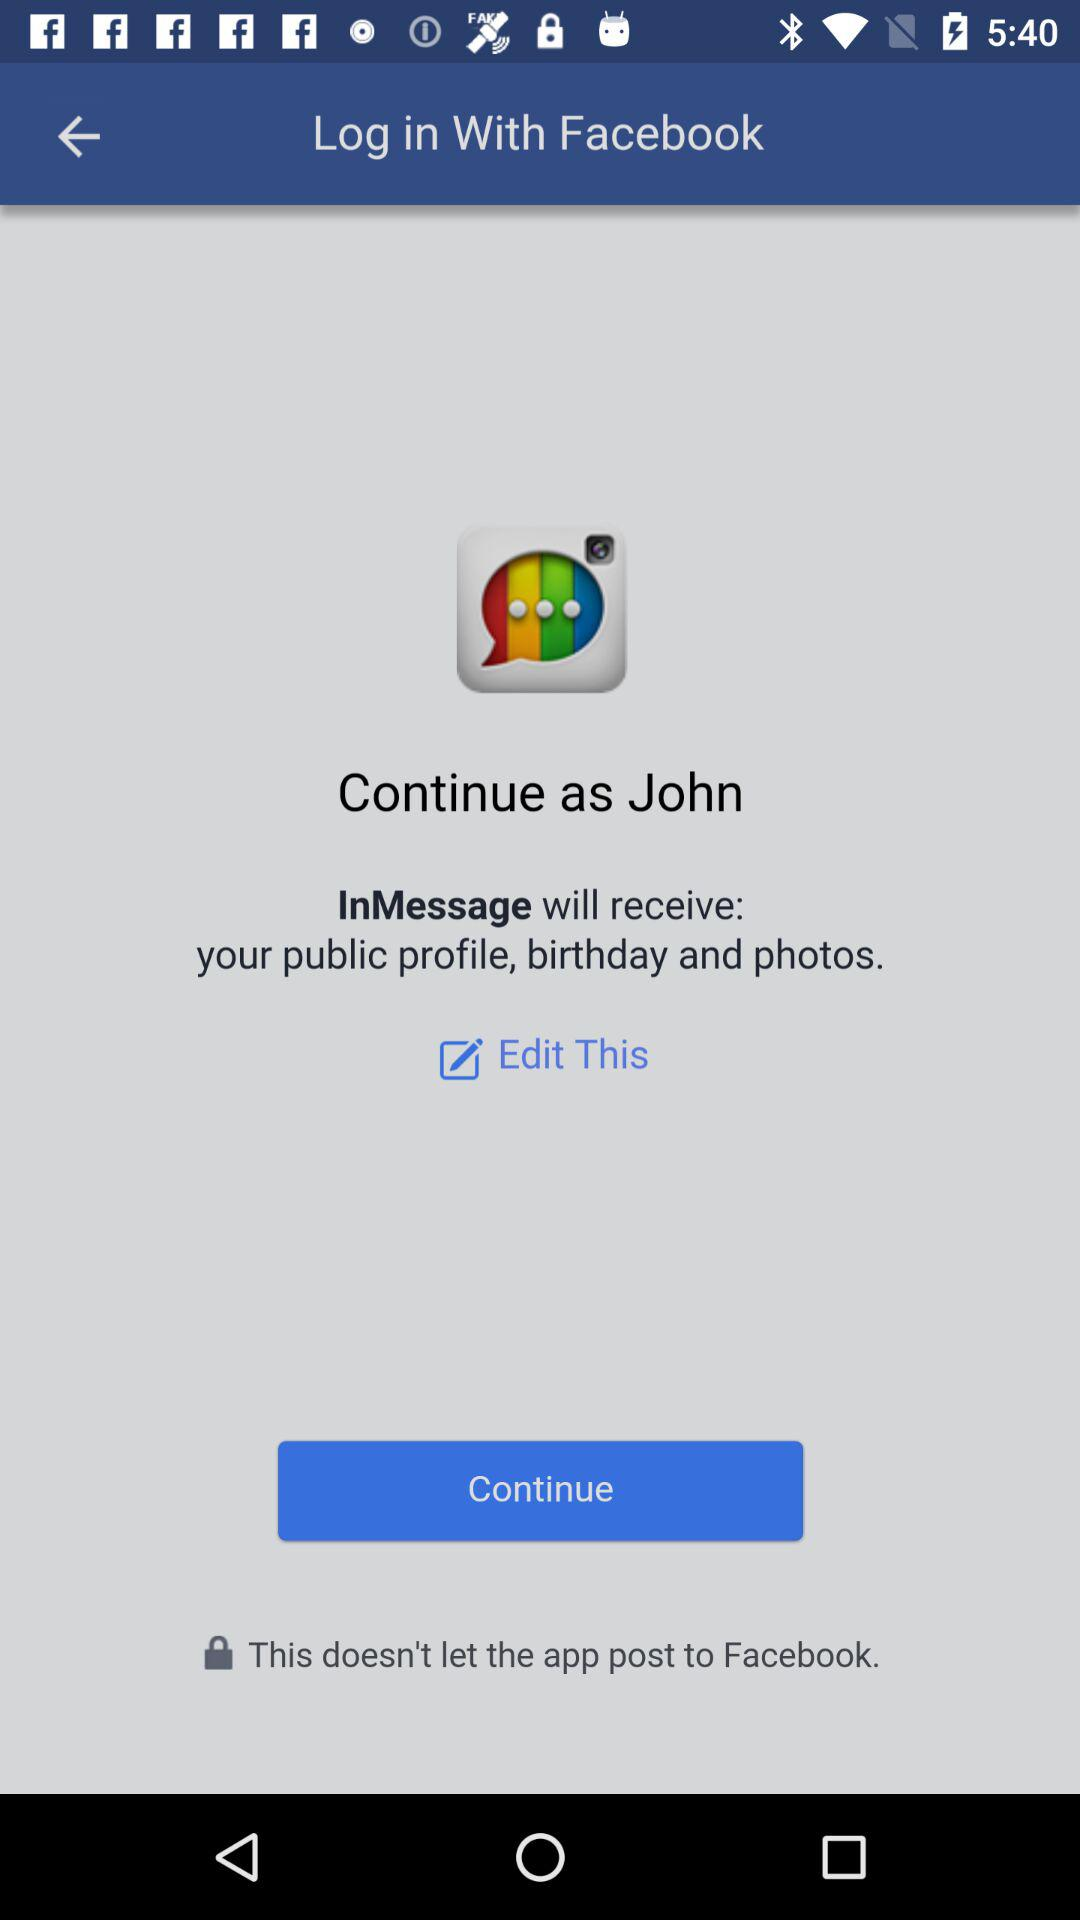What is the user name? The user name is John. 